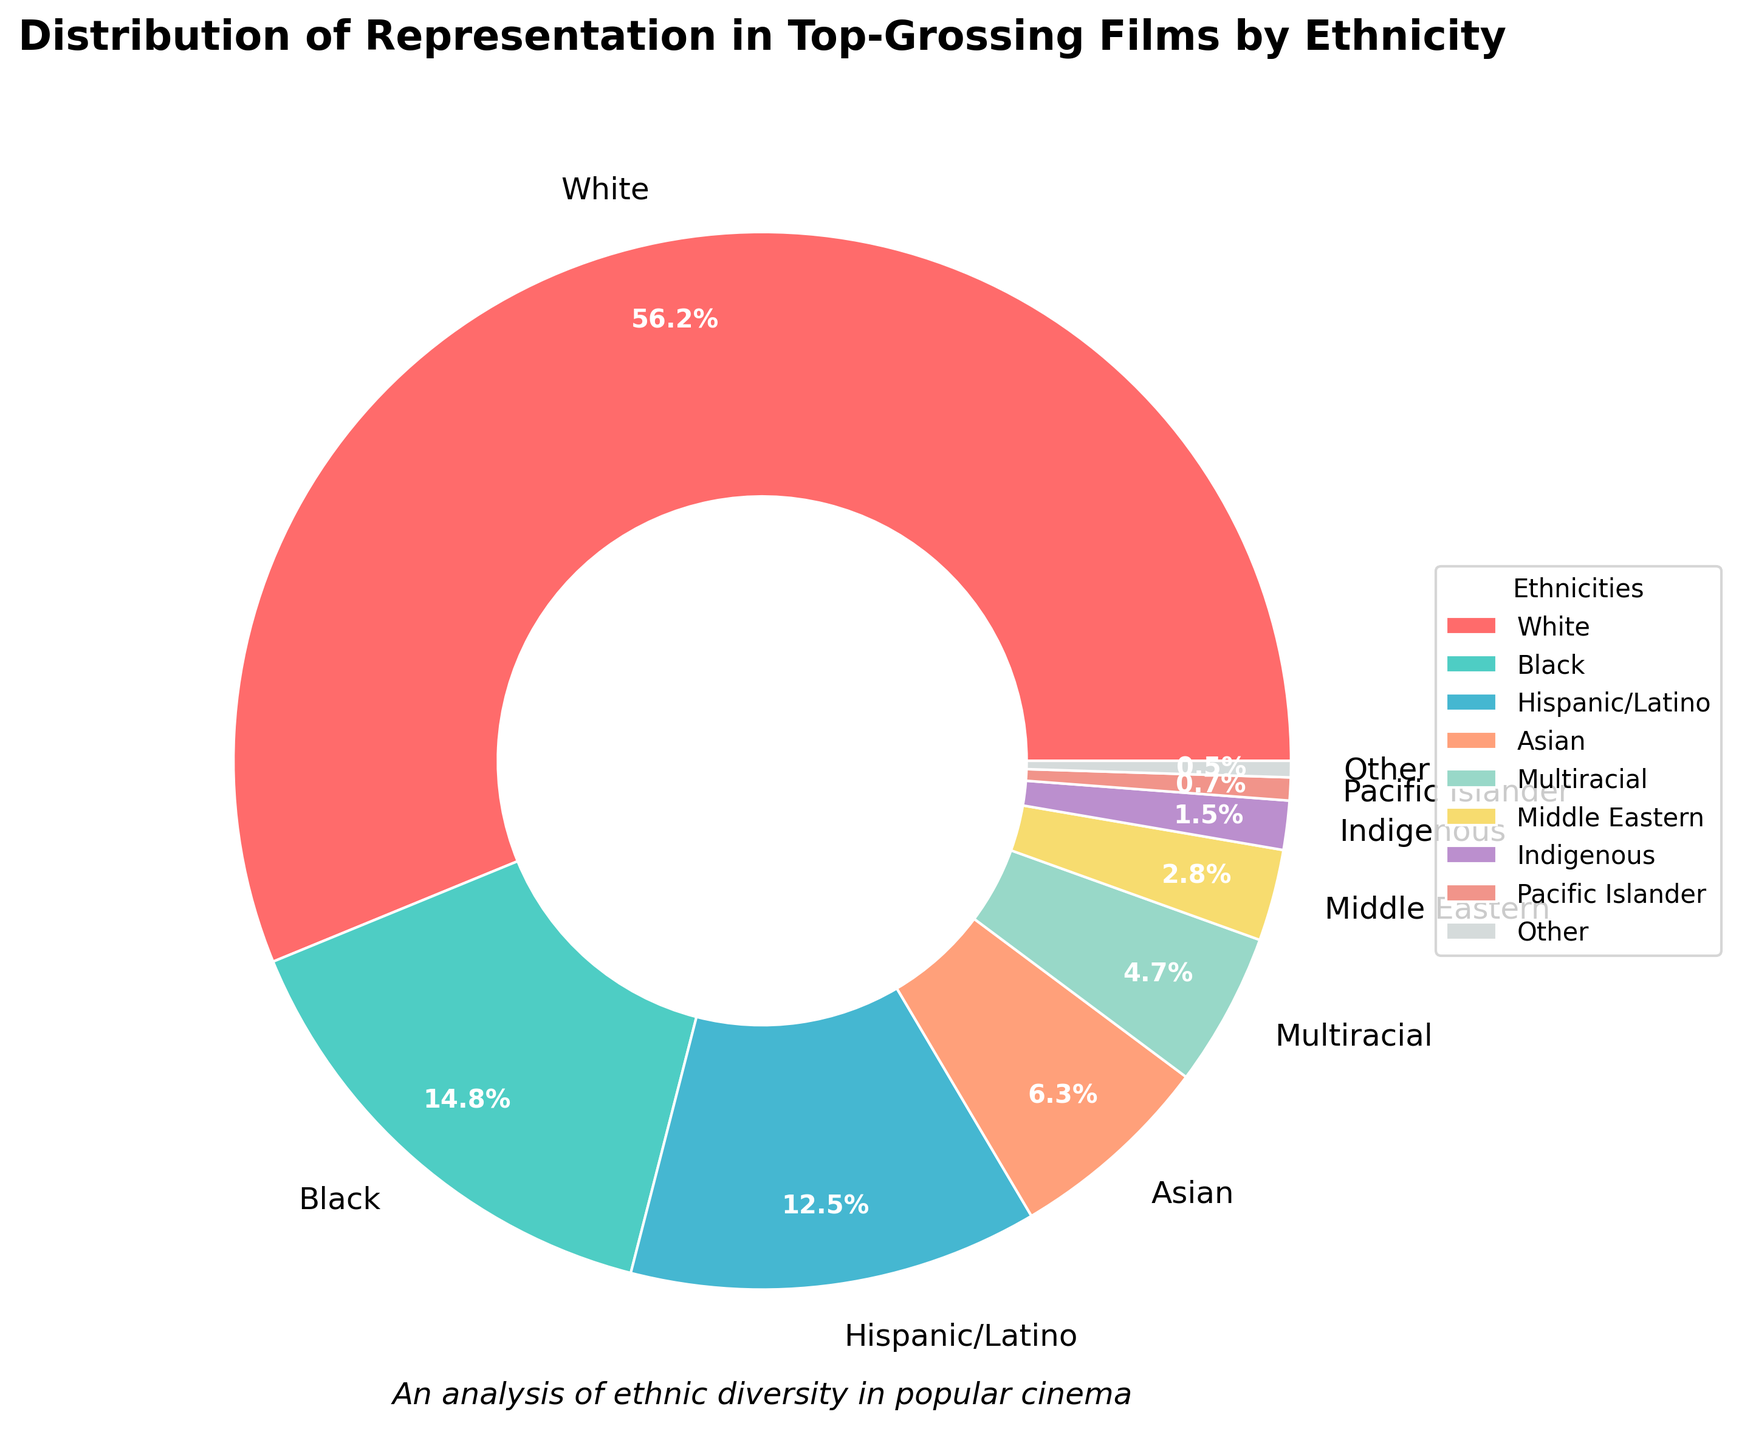What percentage of the representation is accounted for by White and Black ethnicities together? To find the combined percentage, add the percentages of White (56.2%) and Black (14.8%) ethnicities together. 56.2 + 14.8 = 71.
Answer: 71% Which ethnicity has the second-highest representation in top-grossing films? By observing the percentages, the ethnicity with the second-highest representation is the one with the highest value after White. Black has 14.8%, which is the second-highest.
Answer: Black Is the representation of Hispanic/Latino ethnicity higher or lower than that of Asian ethnicity? Compare the percentage of Hispanic/Latino (12.5%) with Asian (6.3%). 12.5 is greater than 6.3, so Hispanic/Latino representation is higher.
Answer: Higher What is the combined representation of Multiracial, Middle Eastern, and Indigenous ethnicities? Add the percentages of Multiracial (4.7%), Middle Eastern (2.8%), and Indigenous (1.5%). 4.7 + 2.8 + 1.5 = 9.
Answer: 9% How does the representation of Pacific Islander ethnicity compare to that of Other ethnicities? Compare the percentages of Pacific Islander (0.7%) with Other (0.5%). 0.7 is greater than 0.5.
Answer: Greater What is the difference in representation between White and Asian ethnicities? Subtract the percentage of Asian (6.3%) from the percentage of White (56.2%). 56.2 - 6.3 = 49.9.
Answer: 49.9% What is the total representation of all ethnicities combined? To find the total percentage, add up all the given percentages. 56.2 + 14.8 + 12.5 + 6.3 + 4.7 + 2.8 + 1.5 + 0.7 + 0.5 = 100.
Answer: 100% Which ethnic group has the smallest representation in top-grossing films? Identify the ethnic group with the smallest percentage value. Other has the smallest percentage with 0.5%.
Answer: Other What is the cumulative representation of groups with less than 5% each? Add the percentages of all groups with less than 5%: Multiracial (4.7%), Middle Eastern (2.8%), Indigenous (1.5%), Pacific Islander (0.7%), and Other (0.5%). 4.7 + 2.8 + 1.5 + 0.7 + 0.5 = 10.2.
Answer: 10.2% How much more representation does the White ethnicity have compared to Hispanic/Latino? Subtract the percentage of Hispanic/Latino (12.5%) from the percentage of White (56.2%). 56.2 - 12.5 = 43.7.
Answer: 43.7% 